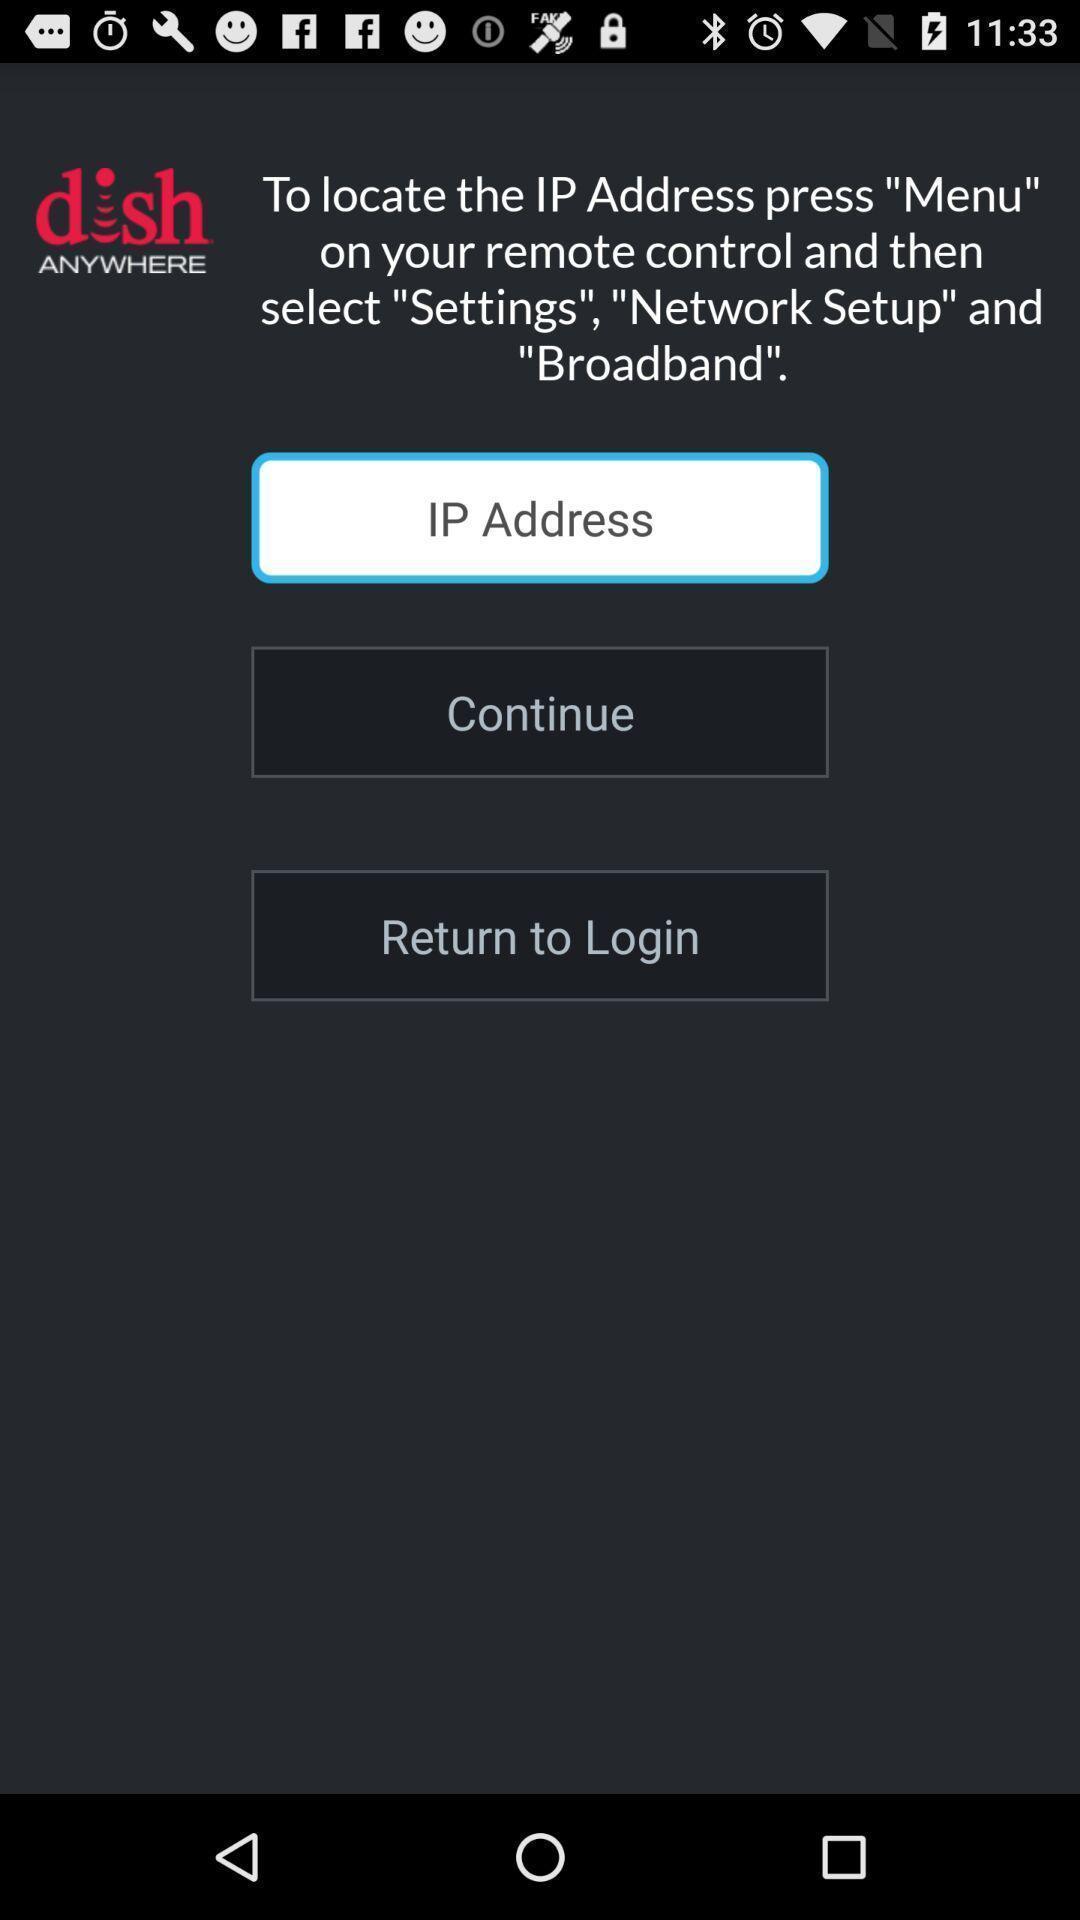Describe the content in this image. Screen displaying ip address. 